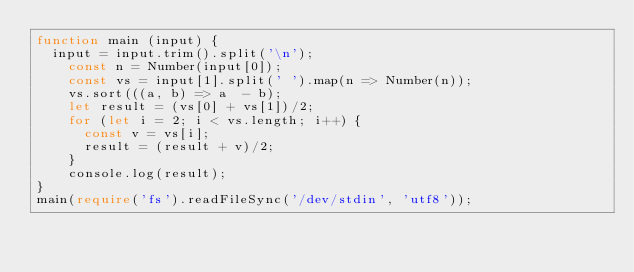Convert code to text. <code><loc_0><loc_0><loc_500><loc_500><_TypeScript_>function main (input) {
	input = input.trim().split('\n');
  	const n = Number(input[0]);
  	const vs = input[1].split(' ').map(n => Number(n));
  	vs.sort(((a, b) => a  - b);
  	let result = (vs[0] + vs[1])/2;
  	for (let i = 2; i < vs.length; i++) {
      const v = vs[i];
      result = (result + v)/2;
    }
  	console.log(result);
}
main(require('fs').readFileSync('/dev/stdin', 'utf8'));
</code> 